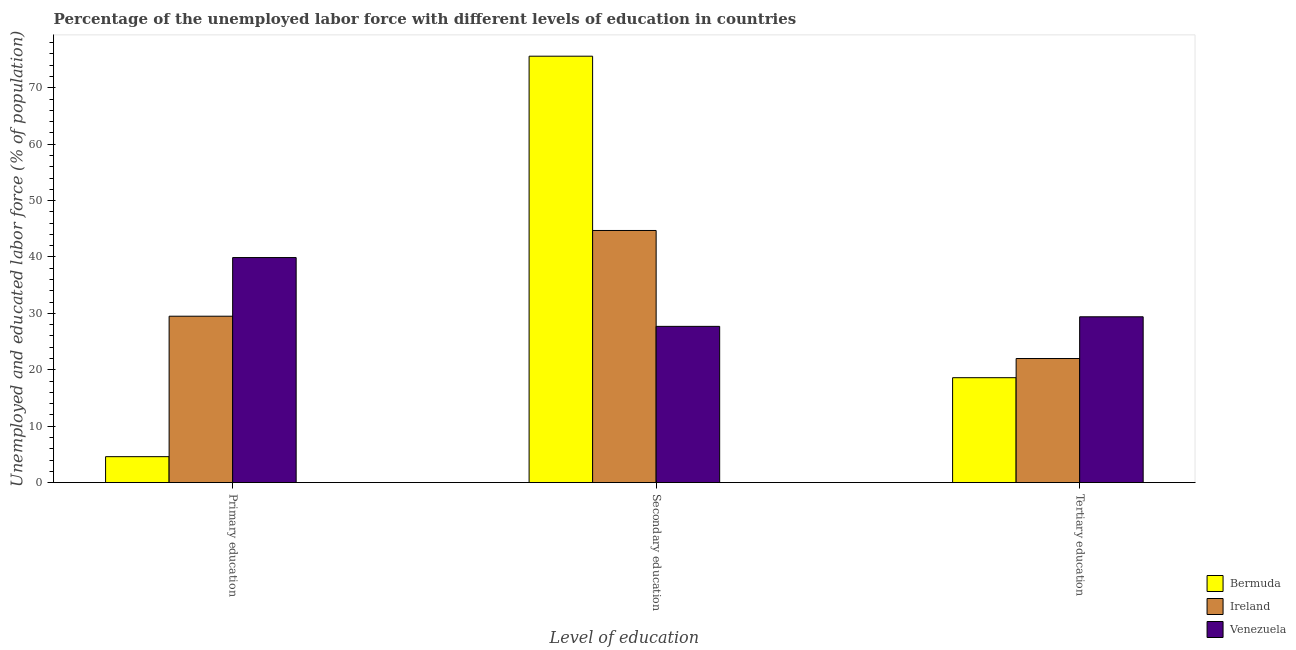How many groups of bars are there?
Your answer should be compact. 3. Are the number of bars per tick equal to the number of legend labels?
Your answer should be very brief. Yes. Are the number of bars on each tick of the X-axis equal?
Your response must be concise. Yes. How many bars are there on the 2nd tick from the left?
Make the answer very short. 3. How many bars are there on the 3rd tick from the right?
Keep it short and to the point. 3. What is the label of the 1st group of bars from the left?
Provide a succinct answer. Primary education. What is the percentage of labor force who received tertiary education in Bermuda?
Provide a short and direct response. 18.6. Across all countries, what is the maximum percentage of labor force who received tertiary education?
Offer a terse response. 29.4. Across all countries, what is the minimum percentage of labor force who received primary education?
Provide a short and direct response. 4.6. In which country was the percentage of labor force who received secondary education maximum?
Keep it short and to the point. Bermuda. In which country was the percentage of labor force who received tertiary education minimum?
Give a very brief answer. Bermuda. What is the difference between the percentage of labor force who received primary education in Bermuda and that in Venezuela?
Offer a terse response. -35.3. What is the difference between the percentage of labor force who received secondary education in Venezuela and the percentage of labor force who received tertiary education in Bermuda?
Provide a succinct answer. 9.1. What is the average percentage of labor force who received tertiary education per country?
Ensure brevity in your answer.  23.33. What is the difference between the percentage of labor force who received primary education and percentage of labor force who received secondary education in Venezuela?
Ensure brevity in your answer.  12.2. In how many countries, is the percentage of labor force who received primary education greater than 62 %?
Your answer should be compact. 0. What is the ratio of the percentage of labor force who received secondary education in Venezuela to that in Ireland?
Provide a short and direct response. 0.62. What is the difference between the highest and the second highest percentage of labor force who received secondary education?
Your answer should be compact. 30.9. What is the difference between the highest and the lowest percentage of labor force who received primary education?
Give a very brief answer. 35.3. In how many countries, is the percentage of labor force who received primary education greater than the average percentage of labor force who received primary education taken over all countries?
Make the answer very short. 2. Is the sum of the percentage of labor force who received primary education in Bermuda and Venezuela greater than the maximum percentage of labor force who received secondary education across all countries?
Provide a succinct answer. No. What does the 3rd bar from the left in Tertiary education represents?
Offer a terse response. Venezuela. What does the 2nd bar from the right in Tertiary education represents?
Your answer should be compact. Ireland. Is it the case that in every country, the sum of the percentage of labor force who received primary education and percentage of labor force who received secondary education is greater than the percentage of labor force who received tertiary education?
Your answer should be compact. Yes. Are all the bars in the graph horizontal?
Your answer should be very brief. No. How many countries are there in the graph?
Your answer should be very brief. 3. What is the difference between two consecutive major ticks on the Y-axis?
Give a very brief answer. 10. Does the graph contain grids?
Make the answer very short. No. Where does the legend appear in the graph?
Make the answer very short. Bottom right. What is the title of the graph?
Keep it short and to the point. Percentage of the unemployed labor force with different levels of education in countries. Does "Togo" appear as one of the legend labels in the graph?
Your response must be concise. No. What is the label or title of the X-axis?
Your response must be concise. Level of education. What is the label or title of the Y-axis?
Give a very brief answer. Unemployed and educated labor force (% of population). What is the Unemployed and educated labor force (% of population) in Bermuda in Primary education?
Your answer should be very brief. 4.6. What is the Unemployed and educated labor force (% of population) in Ireland in Primary education?
Make the answer very short. 29.5. What is the Unemployed and educated labor force (% of population) in Venezuela in Primary education?
Your response must be concise. 39.9. What is the Unemployed and educated labor force (% of population) of Bermuda in Secondary education?
Keep it short and to the point. 75.6. What is the Unemployed and educated labor force (% of population) in Ireland in Secondary education?
Offer a terse response. 44.7. What is the Unemployed and educated labor force (% of population) of Venezuela in Secondary education?
Keep it short and to the point. 27.7. What is the Unemployed and educated labor force (% of population) in Bermuda in Tertiary education?
Offer a very short reply. 18.6. What is the Unemployed and educated labor force (% of population) in Ireland in Tertiary education?
Provide a short and direct response. 22. What is the Unemployed and educated labor force (% of population) in Venezuela in Tertiary education?
Give a very brief answer. 29.4. Across all Level of education, what is the maximum Unemployed and educated labor force (% of population) in Bermuda?
Provide a short and direct response. 75.6. Across all Level of education, what is the maximum Unemployed and educated labor force (% of population) in Ireland?
Keep it short and to the point. 44.7. Across all Level of education, what is the maximum Unemployed and educated labor force (% of population) in Venezuela?
Your response must be concise. 39.9. Across all Level of education, what is the minimum Unemployed and educated labor force (% of population) in Bermuda?
Ensure brevity in your answer.  4.6. Across all Level of education, what is the minimum Unemployed and educated labor force (% of population) in Venezuela?
Offer a very short reply. 27.7. What is the total Unemployed and educated labor force (% of population) in Bermuda in the graph?
Offer a terse response. 98.8. What is the total Unemployed and educated labor force (% of population) of Ireland in the graph?
Your response must be concise. 96.2. What is the total Unemployed and educated labor force (% of population) of Venezuela in the graph?
Provide a short and direct response. 97. What is the difference between the Unemployed and educated labor force (% of population) in Bermuda in Primary education and that in Secondary education?
Your answer should be very brief. -71. What is the difference between the Unemployed and educated labor force (% of population) in Ireland in Primary education and that in Secondary education?
Your answer should be very brief. -15.2. What is the difference between the Unemployed and educated labor force (% of population) in Bermuda in Primary education and that in Tertiary education?
Provide a short and direct response. -14. What is the difference between the Unemployed and educated labor force (% of population) in Venezuela in Primary education and that in Tertiary education?
Your response must be concise. 10.5. What is the difference between the Unemployed and educated labor force (% of population) in Bermuda in Secondary education and that in Tertiary education?
Your answer should be very brief. 57. What is the difference between the Unemployed and educated labor force (% of population) in Ireland in Secondary education and that in Tertiary education?
Offer a terse response. 22.7. What is the difference between the Unemployed and educated labor force (% of population) in Venezuela in Secondary education and that in Tertiary education?
Make the answer very short. -1.7. What is the difference between the Unemployed and educated labor force (% of population) in Bermuda in Primary education and the Unemployed and educated labor force (% of population) in Ireland in Secondary education?
Your answer should be compact. -40.1. What is the difference between the Unemployed and educated labor force (% of population) in Bermuda in Primary education and the Unemployed and educated labor force (% of population) in Venezuela in Secondary education?
Offer a very short reply. -23.1. What is the difference between the Unemployed and educated labor force (% of population) in Ireland in Primary education and the Unemployed and educated labor force (% of population) in Venezuela in Secondary education?
Make the answer very short. 1.8. What is the difference between the Unemployed and educated labor force (% of population) in Bermuda in Primary education and the Unemployed and educated labor force (% of population) in Ireland in Tertiary education?
Ensure brevity in your answer.  -17.4. What is the difference between the Unemployed and educated labor force (% of population) in Bermuda in Primary education and the Unemployed and educated labor force (% of population) in Venezuela in Tertiary education?
Provide a short and direct response. -24.8. What is the difference between the Unemployed and educated labor force (% of population) of Ireland in Primary education and the Unemployed and educated labor force (% of population) of Venezuela in Tertiary education?
Provide a succinct answer. 0.1. What is the difference between the Unemployed and educated labor force (% of population) of Bermuda in Secondary education and the Unemployed and educated labor force (% of population) of Ireland in Tertiary education?
Provide a short and direct response. 53.6. What is the difference between the Unemployed and educated labor force (% of population) of Bermuda in Secondary education and the Unemployed and educated labor force (% of population) of Venezuela in Tertiary education?
Offer a terse response. 46.2. What is the average Unemployed and educated labor force (% of population) in Bermuda per Level of education?
Provide a short and direct response. 32.93. What is the average Unemployed and educated labor force (% of population) of Ireland per Level of education?
Give a very brief answer. 32.07. What is the average Unemployed and educated labor force (% of population) of Venezuela per Level of education?
Give a very brief answer. 32.33. What is the difference between the Unemployed and educated labor force (% of population) of Bermuda and Unemployed and educated labor force (% of population) of Ireland in Primary education?
Provide a short and direct response. -24.9. What is the difference between the Unemployed and educated labor force (% of population) of Bermuda and Unemployed and educated labor force (% of population) of Venezuela in Primary education?
Keep it short and to the point. -35.3. What is the difference between the Unemployed and educated labor force (% of population) of Ireland and Unemployed and educated labor force (% of population) of Venezuela in Primary education?
Ensure brevity in your answer.  -10.4. What is the difference between the Unemployed and educated labor force (% of population) in Bermuda and Unemployed and educated labor force (% of population) in Ireland in Secondary education?
Keep it short and to the point. 30.9. What is the difference between the Unemployed and educated labor force (% of population) of Bermuda and Unemployed and educated labor force (% of population) of Venezuela in Secondary education?
Your response must be concise. 47.9. What is the difference between the Unemployed and educated labor force (% of population) of Ireland and Unemployed and educated labor force (% of population) of Venezuela in Secondary education?
Provide a short and direct response. 17. What is the difference between the Unemployed and educated labor force (% of population) of Ireland and Unemployed and educated labor force (% of population) of Venezuela in Tertiary education?
Provide a short and direct response. -7.4. What is the ratio of the Unemployed and educated labor force (% of population) in Bermuda in Primary education to that in Secondary education?
Your answer should be compact. 0.06. What is the ratio of the Unemployed and educated labor force (% of population) of Ireland in Primary education to that in Secondary education?
Your answer should be very brief. 0.66. What is the ratio of the Unemployed and educated labor force (% of population) of Venezuela in Primary education to that in Secondary education?
Keep it short and to the point. 1.44. What is the ratio of the Unemployed and educated labor force (% of population) in Bermuda in Primary education to that in Tertiary education?
Offer a very short reply. 0.25. What is the ratio of the Unemployed and educated labor force (% of population) in Ireland in Primary education to that in Tertiary education?
Offer a terse response. 1.34. What is the ratio of the Unemployed and educated labor force (% of population) of Venezuela in Primary education to that in Tertiary education?
Provide a succinct answer. 1.36. What is the ratio of the Unemployed and educated labor force (% of population) of Bermuda in Secondary education to that in Tertiary education?
Offer a very short reply. 4.06. What is the ratio of the Unemployed and educated labor force (% of population) in Ireland in Secondary education to that in Tertiary education?
Ensure brevity in your answer.  2.03. What is the ratio of the Unemployed and educated labor force (% of population) in Venezuela in Secondary education to that in Tertiary education?
Provide a short and direct response. 0.94. What is the difference between the highest and the second highest Unemployed and educated labor force (% of population) of Ireland?
Keep it short and to the point. 15.2. What is the difference between the highest and the second highest Unemployed and educated labor force (% of population) of Venezuela?
Ensure brevity in your answer.  10.5. What is the difference between the highest and the lowest Unemployed and educated labor force (% of population) in Ireland?
Provide a short and direct response. 22.7. What is the difference between the highest and the lowest Unemployed and educated labor force (% of population) of Venezuela?
Offer a terse response. 12.2. 